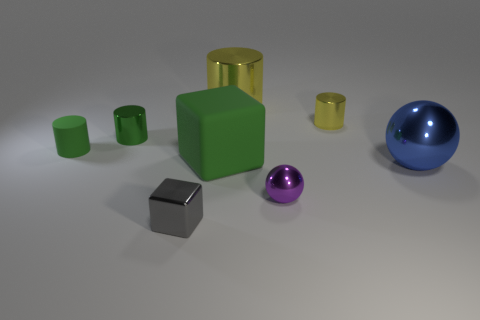What shape is the metal object that is the same color as the matte cube?
Offer a very short reply. Cylinder. There is a large blue thing that is made of the same material as the tiny cube; what shape is it?
Offer a very short reply. Sphere. What is the size of the purple metallic thing?
Ensure brevity in your answer.  Small. Does the blue object have the same size as the green metallic thing?
Offer a very short reply. No. What number of things are tiny things in front of the small green shiny object or objects on the left side of the big ball?
Your answer should be very brief. 7. There is a small green object in front of the small metal cylinder that is left of the metallic cube; how many tiny metal cubes are behind it?
Ensure brevity in your answer.  0. There is a sphere that is in front of the big blue thing; what size is it?
Your answer should be compact. Small. What number of green matte cubes are the same size as the matte cylinder?
Ensure brevity in your answer.  0. Does the purple thing have the same size as the sphere to the right of the purple object?
Provide a short and direct response. No. What number of things are green cylinders or blue balls?
Keep it short and to the point. 3. 